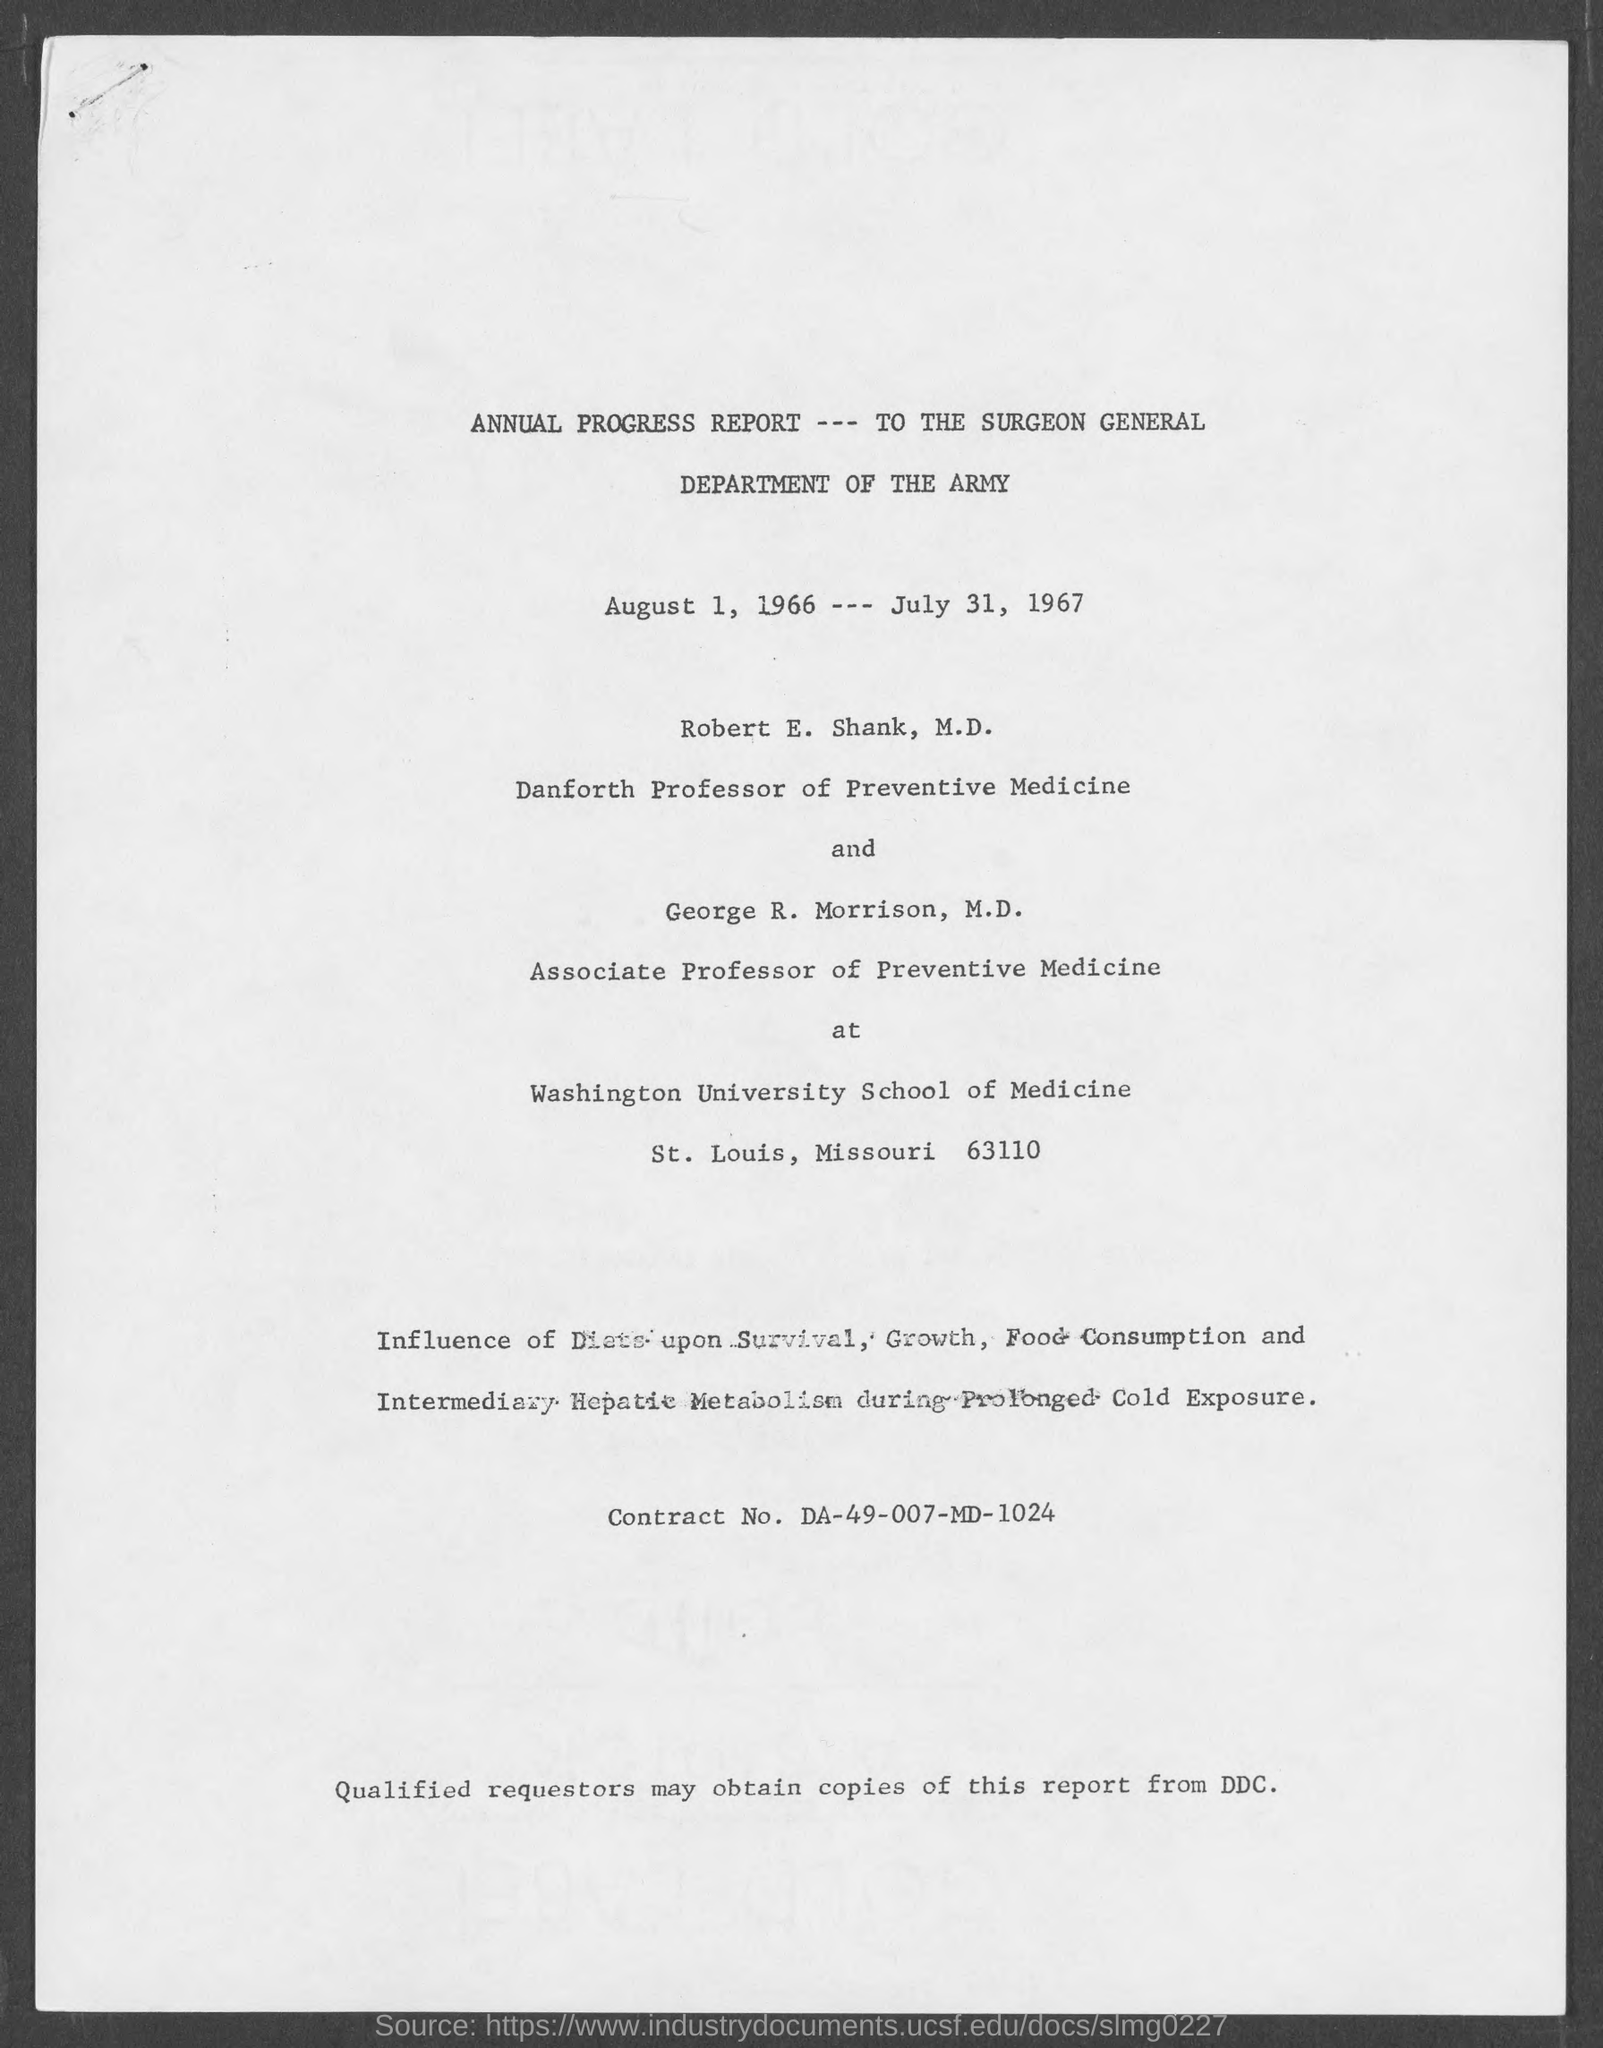What is the name of the department mentioned in the given form ?
Offer a very short reply. Department of the Army. What is the designation of robert e. shank as mentioned in the given form ?
Make the answer very short. Danforth Professor of Preventive Medicine. What is the designation of george r. morrison as mentioned in the given form ?
Ensure brevity in your answer.  Associate professor of preventive medicine. What is the contract no. mentioned in the given page ?
Offer a terse response. DA-49-007-MD-1024. What is the name of the report mentioned in the given page ?
Keep it short and to the point. Annual progress report. 